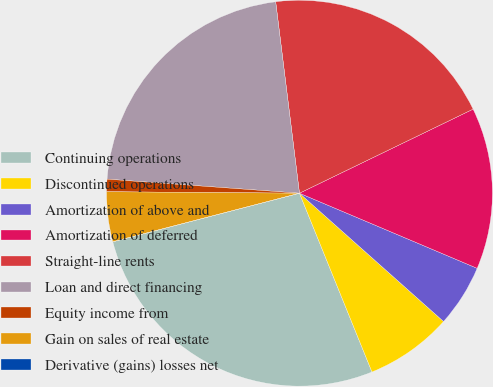<chart> <loc_0><loc_0><loc_500><loc_500><pie_chart><fcel>Continuing operations<fcel>Discontinued operations<fcel>Amortization of above and<fcel>Amortization of deferred<fcel>Straight-line rents<fcel>Loan and direct financing<fcel>Equity income from<fcel>Gain on sales of real estate<fcel>Derivative (gains) losses net<nl><fcel>27.08%<fcel>7.29%<fcel>5.21%<fcel>13.54%<fcel>19.79%<fcel>21.87%<fcel>1.04%<fcel>4.17%<fcel>0.0%<nl></chart> 